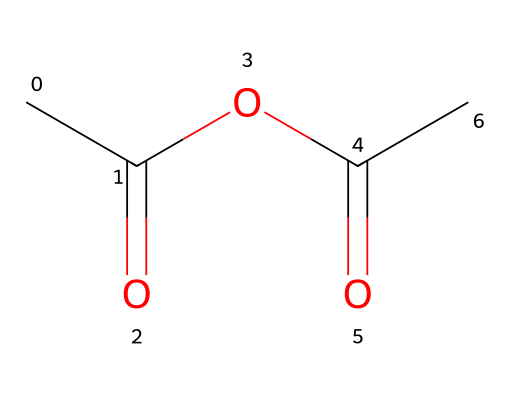how many carbon atoms are present in this molecule? By examining the SMILES representation, we identify each "C" that represents a carbon atom. The SMILES shows a total of 4 carbon atoms in the structure.
Answer: 4 what is the functional group featured in this chemical? The structure contains an anhydride functional group, which can be identified by the presence of two acyl groups (C=O) linked to the same oxygen atom.
Answer: anhydride how many double bonds are in this compound? Looking at the chemical structure, there are two double bonds, both between carbon and oxygen (C=O).
Answer: 2 what type of reaction can this acid anhydride undergo? Acid anhydrides typically participate in hydrolysis reactions, leading to the formation of corresponding acids when reacted with water.
Answer: hydrolysis is this chemical polar or nonpolar? The presence of the polar bonds (C=O) suggests that the molecule has polar characteristics due to uneven electron distribution, particularly because oxygen is more electronegative than carbon.
Answer: polar how does the presence of anhydride affect its reactivity? Anhydrides are generally more reactive than their corresponding acids because they can easily undergo nucleophilic attack, making them versatile intermediates in organic synthesis.
Answer: more reactive what is the primary use of acid anhydrides in exhaust gas treatment? Acid anhydrides can act as intermediates in the synthesis of various catalytic compounds that help in the reduction of harmful emissions from exhaust gases.
Answer: catalysts 